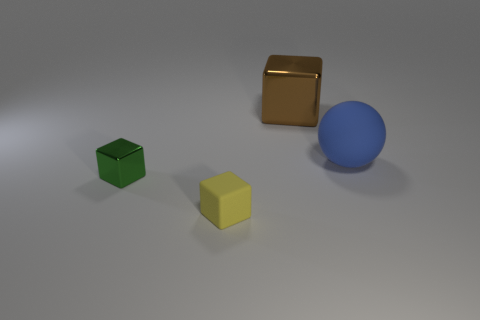There is a large object that is right of the brown metal thing; what is it made of?
Your response must be concise. Rubber. There is a object that is behind the green thing and in front of the large brown thing; what is its shape?
Your answer should be compact. Sphere. What is the ball made of?
Keep it short and to the point. Rubber. How many cubes are either big metal things or tiny yellow things?
Your response must be concise. 2. Do the big sphere and the small green thing have the same material?
Your answer should be compact. No. There is another shiny object that is the same shape as the small shiny thing; what is its size?
Your answer should be very brief. Large. There is a thing that is both behind the tiny green metal thing and on the left side of the blue object; what material is it made of?
Keep it short and to the point. Metal. Is the number of small yellow objects in front of the big sphere the same as the number of large blocks?
Offer a terse response. Yes. How many things are either metallic things behind the blue matte sphere or cyan matte cubes?
Ensure brevity in your answer.  1. There is a shiny thing that is on the left side of the brown thing; is it the same color as the rubber block?
Make the answer very short. No. 